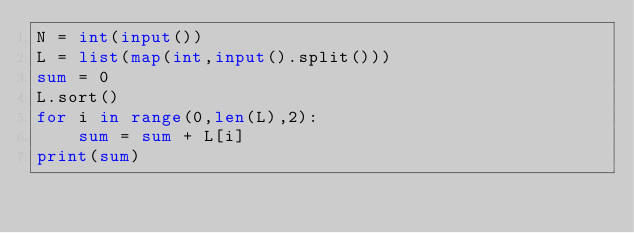<code> <loc_0><loc_0><loc_500><loc_500><_Python_>N = int(input())
L = list(map(int,input().split()))
sum = 0
L.sort()
for i in range(0,len(L),2):
    sum = sum + L[i]
print(sum)</code> 